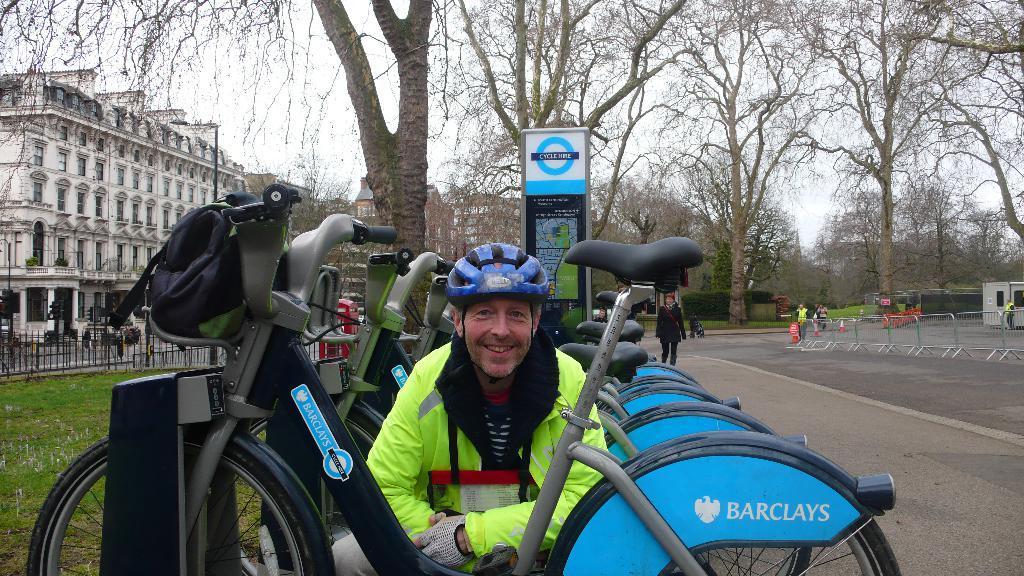Please provide a concise description of this image. This picture is clicked outside. In the center we can see the group of bicycles parked on the ground and we can see person wearing helmet and seems to be squatting on the ground. On the right we can see the group of persons, metal rods, plants and some other objects. On the left we can see the green grass, metal roads and the buildings we can see the light attached to the pole. In the background we can see the sky, trees, buildings and we the text and some picture on the board and some other objects. 